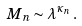Convert formula to latex. <formula><loc_0><loc_0><loc_500><loc_500>M _ { n } \sim \lambda ^ { \kappa _ { n } } \, .</formula> 